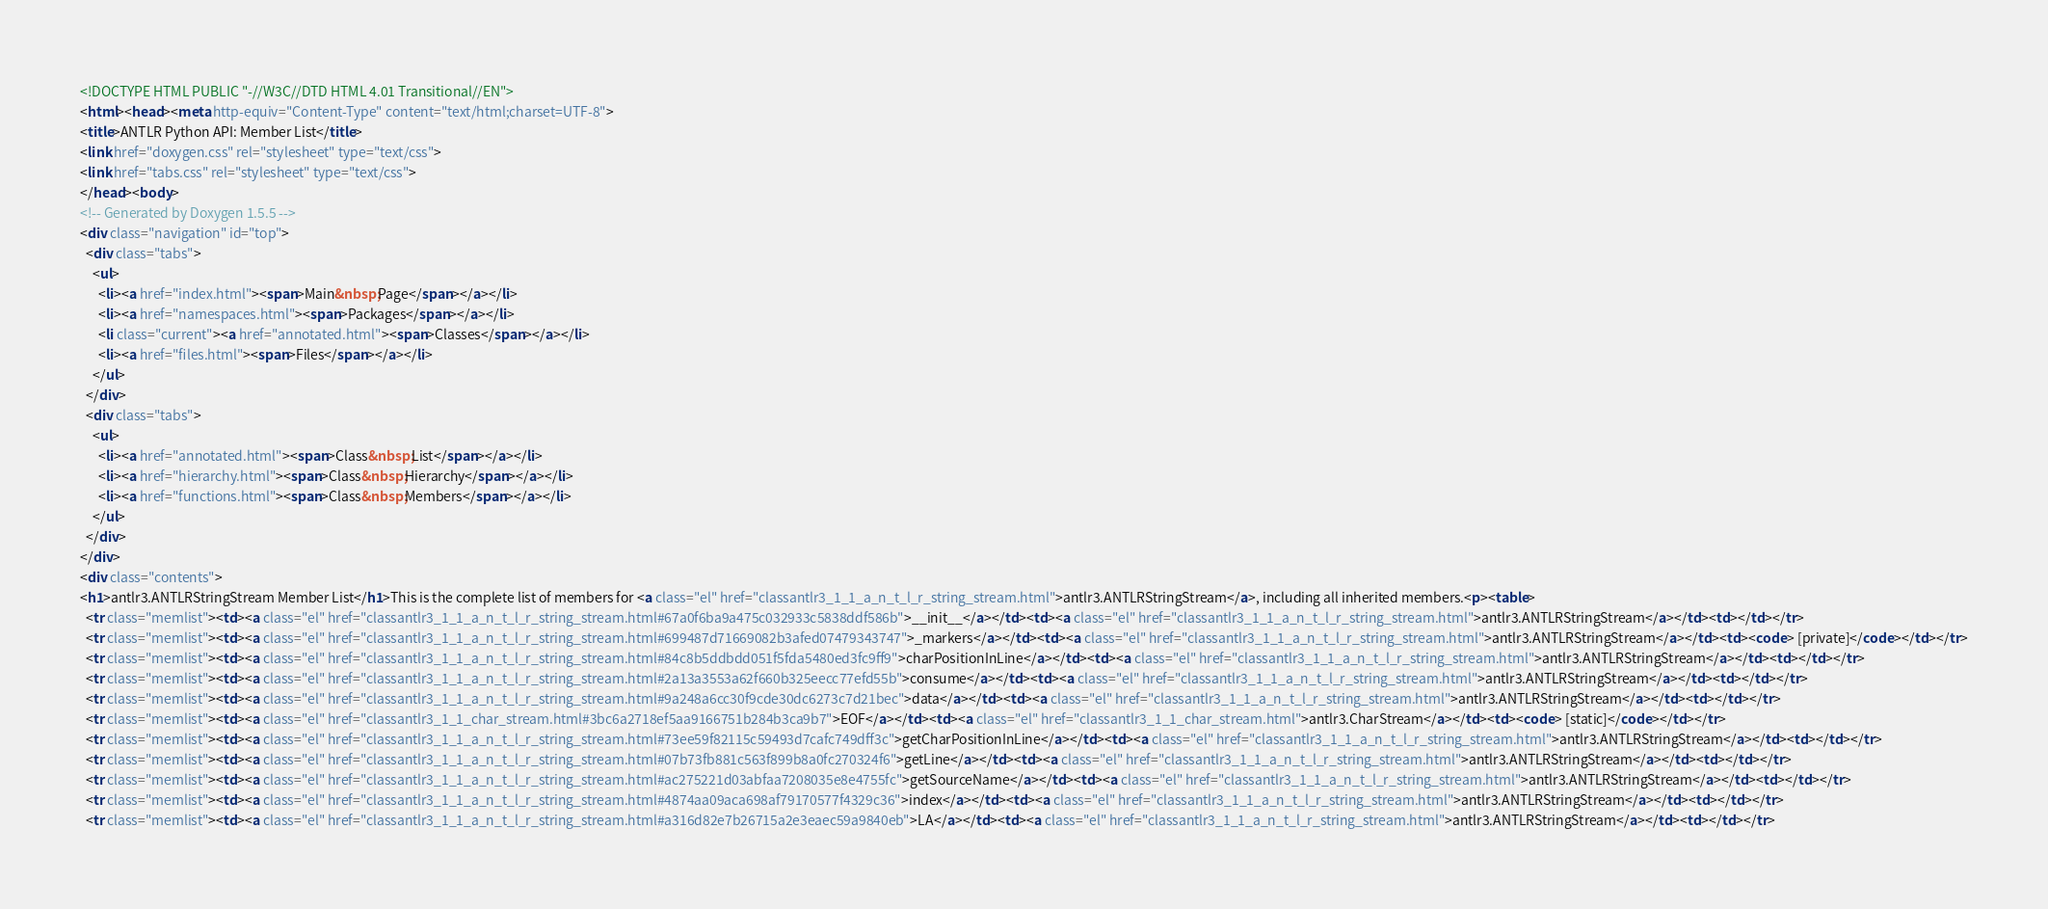Convert code to text. <code><loc_0><loc_0><loc_500><loc_500><_HTML_><!DOCTYPE HTML PUBLIC "-//W3C//DTD HTML 4.01 Transitional//EN">
<html><head><meta http-equiv="Content-Type" content="text/html;charset=UTF-8">
<title>ANTLR Python API: Member List</title>
<link href="doxygen.css" rel="stylesheet" type="text/css">
<link href="tabs.css" rel="stylesheet" type="text/css">
</head><body>
<!-- Generated by Doxygen 1.5.5 -->
<div class="navigation" id="top">
  <div class="tabs">
    <ul>
      <li><a href="index.html"><span>Main&nbsp;Page</span></a></li>
      <li><a href="namespaces.html"><span>Packages</span></a></li>
      <li class="current"><a href="annotated.html"><span>Classes</span></a></li>
      <li><a href="files.html"><span>Files</span></a></li>
    </ul>
  </div>
  <div class="tabs">
    <ul>
      <li><a href="annotated.html"><span>Class&nbsp;List</span></a></li>
      <li><a href="hierarchy.html"><span>Class&nbsp;Hierarchy</span></a></li>
      <li><a href="functions.html"><span>Class&nbsp;Members</span></a></li>
    </ul>
  </div>
</div>
<div class="contents">
<h1>antlr3.ANTLRStringStream Member List</h1>This is the complete list of members for <a class="el" href="classantlr3_1_1_a_n_t_l_r_string_stream.html">antlr3.ANTLRStringStream</a>, including all inherited members.<p><table>
  <tr class="memlist"><td><a class="el" href="classantlr3_1_1_a_n_t_l_r_string_stream.html#67a0f6ba9a475c032933c5838ddf586b">__init__</a></td><td><a class="el" href="classantlr3_1_1_a_n_t_l_r_string_stream.html">antlr3.ANTLRStringStream</a></td><td></td></tr>
  <tr class="memlist"><td><a class="el" href="classantlr3_1_1_a_n_t_l_r_string_stream.html#699487d71669082b3afed07479343747">_markers</a></td><td><a class="el" href="classantlr3_1_1_a_n_t_l_r_string_stream.html">antlr3.ANTLRStringStream</a></td><td><code> [private]</code></td></tr>
  <tr class="memlist"><td><a class="el" href="classantlr3_1_1_a_n_t_l_r_string_stream.html#84c8b5ddbdd051f5fda5480ed3fc9ff9">charPositionInLine</a></td><td><a class="el" href="classantlr3_1_1_a_n_t_l_r_string_stream.html">antlr3.ANTLRStringStream</a></td><td></td></tr>
  <tr class="memlist"><td><a class="el" href="classantlr3_1_1_a_n_t_l_r_string_stream.html#2a13a3553a62f660b325eecc77efd55b">consume</a></td><td><a class="el" href="classantlr3_1_1_a_n_t_l_r_string_stream.html">antlr3.ANTLRStringStream</a></td><td></td></tr>
  <tr class="memlist"><td><a class="el" href="classantlr3_1_1_a_n_t_l_r_string_stream.html#9a248a6cc30f9cde30dc6273c7d21bec">data</a></td><td><a class="el" href="classantlr3_1_1_a_n_t_l_r_string_stream.html">antlr3.ANTLRStringStream</a></td><td></td></tr>
  <tr class="memlist"><td><a class="el" href="classantlr3_1_1_char_stream.html#3bc6a2718ef5aa9166751b284b3ca9b7">EOF</a></td><td><a class="el" href="classantlr3_1_1_char_stream.html">antlr3.CharStream</a></td><td><code> [static]</code></td></tr>
  <tr class="memlist"><td><a class="el" href="classantlr3_1_1_a_n_t_l_r_string_stream.html#73ee59f82115c59493d7cafc749dff3c">getCharPositionInLine</a></td><td><a class="el" href="classantlr3_1_1_a_n_t_l_r_string_stream.html">antlr3.ANTLRStringStream</a></td><td></td></tr>
  <tr class="memlist"><td><a class="el" href="classantlr3_1_1_a_n_t_l_r_string_stream.html#07b73fb881c563f899b8a0fc270324f6">getLine</a></td><td><a class="el" href="classantlr3_1_1_a_n_t_l_r_string_stream.html">antlr3.ANTLRStringStream</a></td><td></td></tr>
  <tr class="memlist"><td><a class="el" href="classantlr3_1_1_a_n_t_l_r_string_stream.html#ac275221d03abfaa7208035e8e4755fc">getSourceName</a></td><td><a class="el" href="classantlr3_1_1_a_n_t_l_r_string_stream.html">antlr3.ANTLRStringStream</a></td><td></td></tr>
  <tr class="memlist"><td><a class="el" href="classantlr3_1_1_a_n_t_l_r_string_stream.html#4874aa09aca698af79170577f4329c36">index</a></td><td><a class="el" href="classantlr3_1_1_a_n_t_l_r_string_stream.html">antlr3.ANTLRStringStream</a></td><td></td></tr>
  <tr class="memlist"><td><a class="el" href="classantlr3_1_1_a_n_t_l_r_string_stream.html#a316d82e7b26715a2e3eaec59a9840eb">LA</a></td><td><a class="el" href="classantlr3_1_1_a_n_t_l_r_string_stream.html">antlr3.ANTLRStringStream</a></td><td></td></tr></code> 